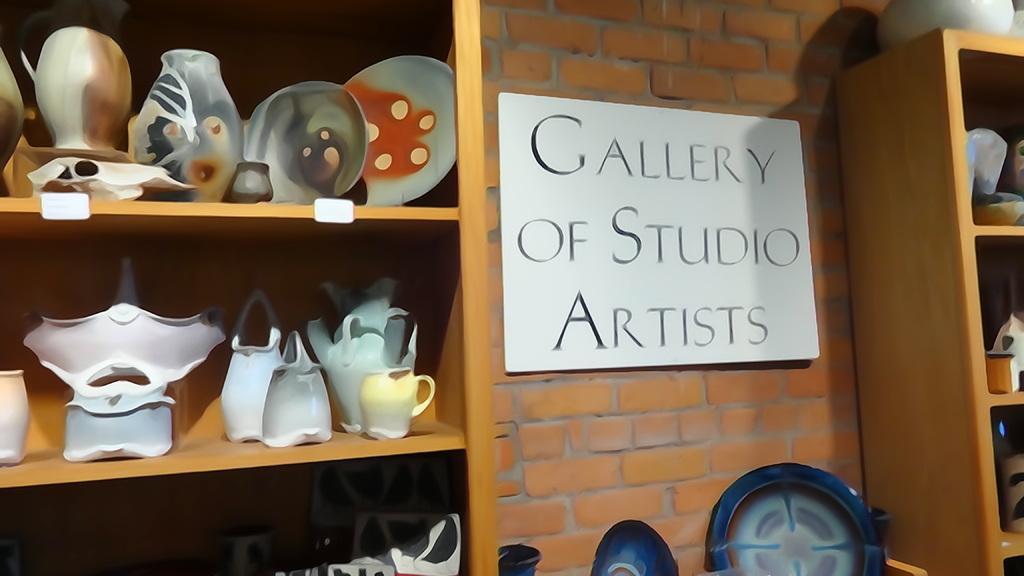Describe this image in one or two sentences. In this image we can see the ceramic jars on the wooden shelf on the left side. Here we can see the billboard on the wall. Here we can see another wooden drawer on the right side. 